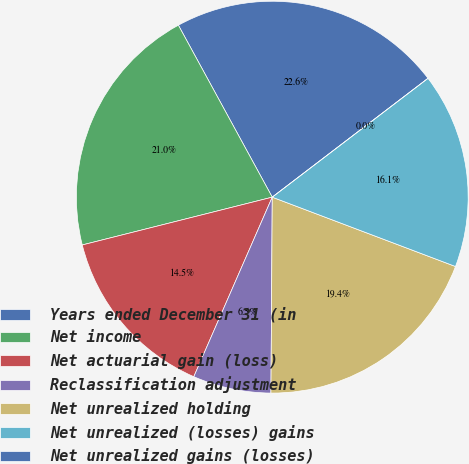<chart> <loc_0><loc_0><loc_500><loc_500><pie_chart><fcel>Years ended December 31 (in<fcel>Net income<fcel>Net actuarial gain (loss)<fcel>Reclassification adjustment<fcel>Net unrealized holding<fcel>Net unrealized (losses) gains<fcel>Net unrealized gains (losses)<nl><fcel>22.58%<fcel>20.97%<fcel>14.52%<fcel>6.45%<fcel>19.35%<fcel>16.13%<fcel>0.0%<nl></chart> 